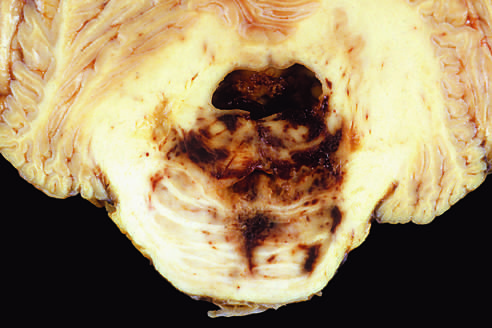does mass effect displace the brain downward?
Answer the question using a single word or phrase. Yes 